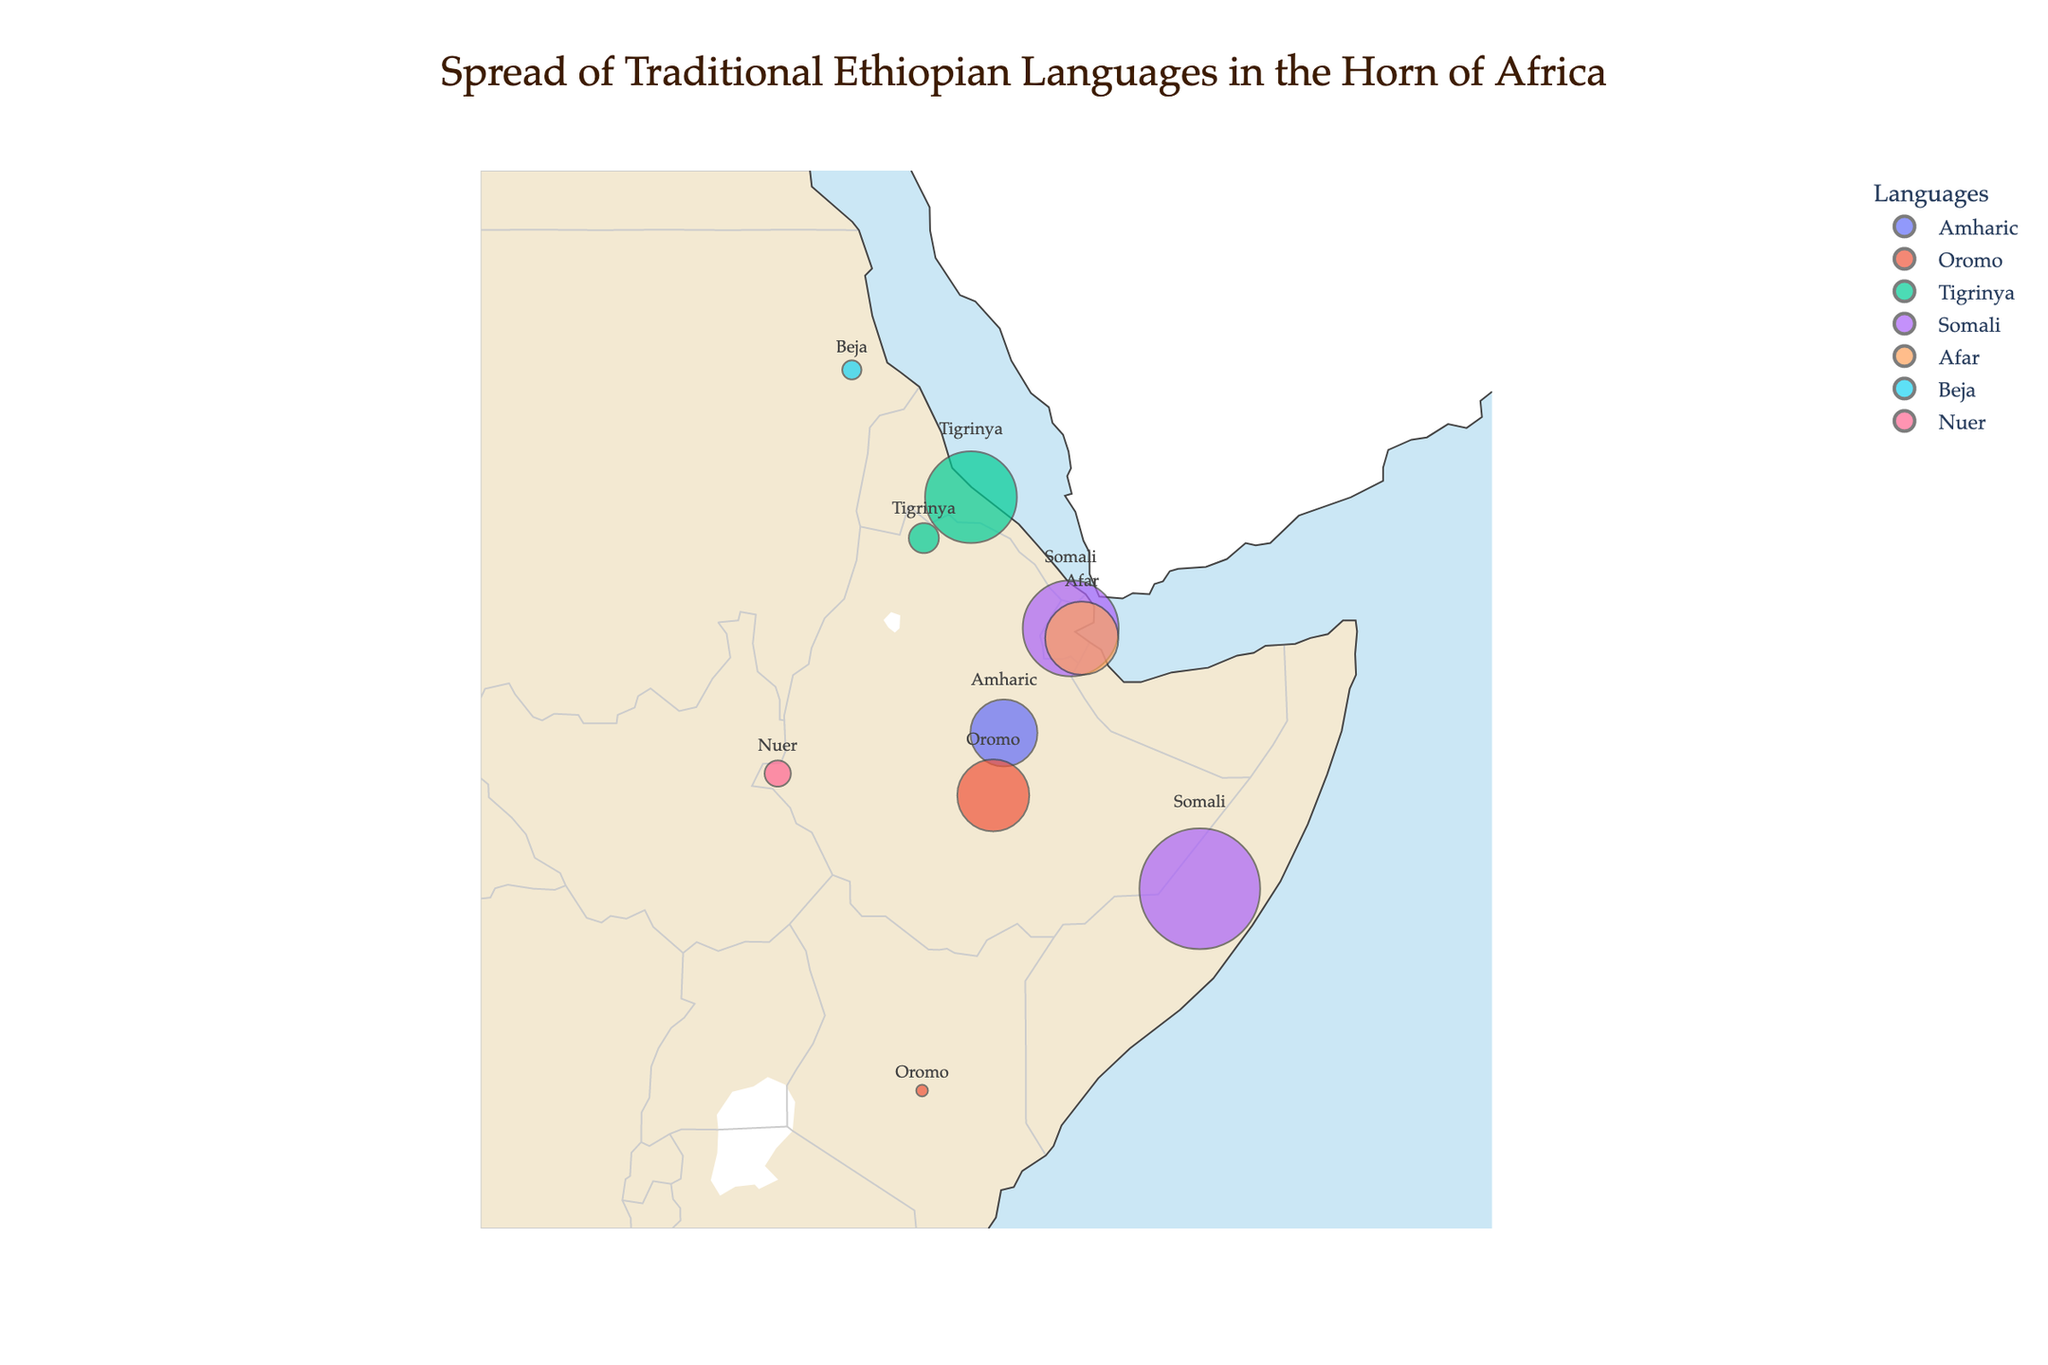What is the title of the figure? The title is usually displayed at the top center of the figure and provides an overview of its content. Here, the title reads "Spread of Traditional Ethiopian Languages in the Horn of Africa."
Answer: Spread of Traditional Ethiopian Languages in the Horn of Africa How many countries are shown in the figure? The countries can be identified by hovering over the scatter points on the map. Each country corresponds to one set of data points. Here, the figure shows data for 6 countries: Ethiopia, Eritrea, Somalia, Djibouti, Kenya, and Sudan.
Answer: 6 Which language has the highest representation in Somalia? By examining the scatter points on the map for Somalia, the Somali language shows a percentage of 95.0 indicating it has the highest representation in Somalia.
Answer: Somali What is the percentage of people speaking Amharic in Ethiopia? The data point for Amharic in Ethiopia is displayed on the map and shows a percentage of 29.3%.
Answer: 29.3% Which language is spoken by 60% of people in Djibouti? Hovering over Djibouti shows the scatter points, revealing that 60% of people in Djibouti speak Somali.
Answer: Somali What is the sum of the percentages of Tigrinya speakers in Ethiopia and Eritrea? The percentages for Tigrinya in Ethiopia and Eritrea are 5.9% and 55.0%, respectively. Adding these percentages gives 5.9 + 55.0 = 60.9%.
Answer: 60.9% Compare the percentages of Somali speakers in Somalia and Djibouti. The scatter points for both countries show that the Somali language has a percentage of 95.0% in Somalia and 60.0% in Djibouti. Therefore, the percentage is higher in Somalia.
Answer: Somalia Which country has the largest percentage for a single language and what is that percentage? By examining all scatter points, Somalia has a data point with 95.0% for Somali, which is the largest percentage for a single language shown in the figure.
Answer: Somalia, 95.0% Are there more Oromo speakers in Kenya or Sudan? The scatter points reveal that Oromo is spoken by 0.9% in Kenya and Beja is spoken by 2.4% in Sudan. Since Oromo in Kenya is directly mentioned and no specific data for Oromo in Sudan, 0.9% > 0%, thus there are more Oromo speakers in Kenya.
Answer: Kenya Which language is spoken by 35% of people in Djibouti? The scatter point for Djibouti shows that 35% of people speak Afar.
Answer: Afar 